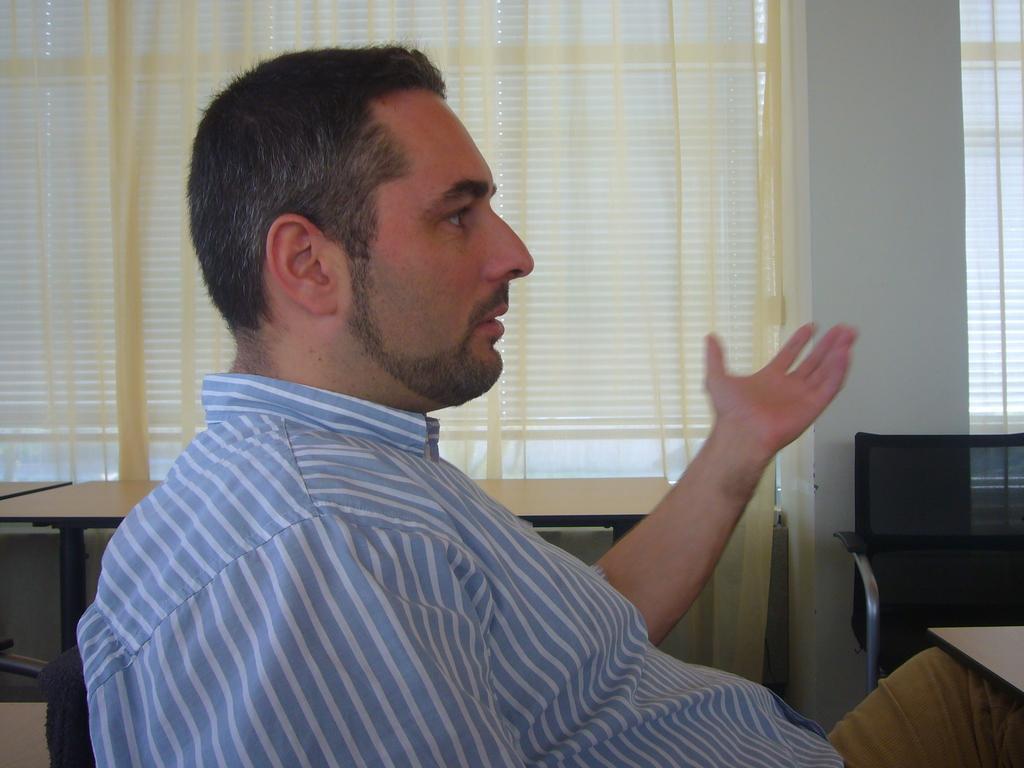Describe this image in one or two sentences. In the given image we can see a man who is sitting on a chair, who is wearing a blue and white color shirt and cream color pant. 